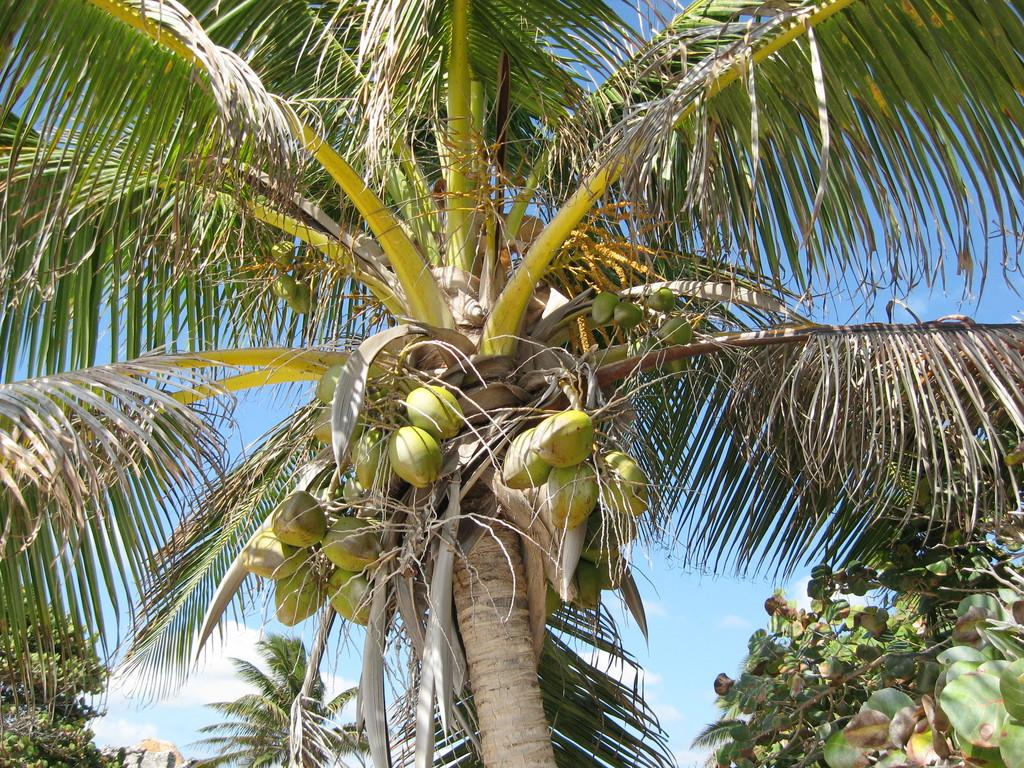What type of vegetation can be seen in the image? There are trees in the image. What part of the natural environment is visible in the image? The sky is visible in the background of the image. What type of powder is being used by the fireman in the image? There is no fireman or powder present in the image. What type of engine is visible in the image? There is no engine present in the image. 